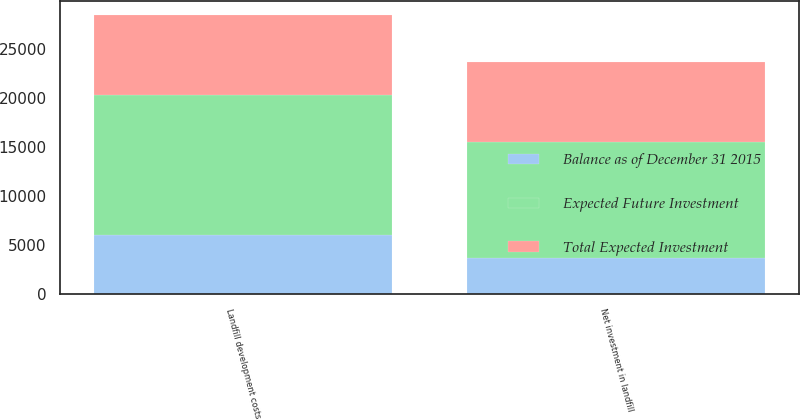Convert chart to OTSL. <chart><loc_0><loc_0><loc_500><loc_500><stacked_bar_chart><ecel><fcel>Landfill development costs<fcel>Net investment in landfill<nl><fcel>Balance as of December 31 2015<fcel>6078.1<fcel>3712.3<nl><fcel>Total Expected Investment<fcel>8153.3<fcel>8153.3<nl><fcel>Expected Future Investment<fcel>14231.4<fcel>11865.6<nl></chart> 